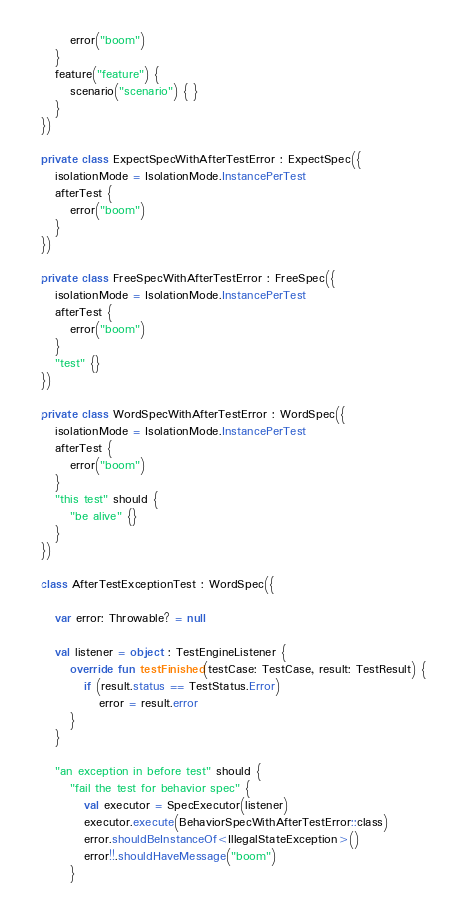Convert code to text. <code><loc_0><loc_0><loc_500><loc_500><_Kotlin_>      error("boom")
   }
   feature("feature") {
      scenario("scenario") { }
   }
})

private class ExpectSpecWithAfterTestError : ExpectSpec({
   isolationMode = IsolationMode.InstancePerTest
   afterTest {
      error("boom")
   }
})

private class FreeSpecWithAfterTestError : FreeSpec({
   isolationMode = IsolationMode.InstancePerTest
   afterTest {
      error("boom")
   }
   "test" {}
})

private class WordSpecWithAfterTestError : WordSpec({
   isolationMode = IsolationMode.InstancePerTest
   afterTest {
      error("boom")
   }
   "this test" should {
      "be alive" {}
   }
})

class AfterTestExceptionTest : WordSpec({

   var error: Throwable? = null

   val listener = object : TestEngineListener {
      override fun testFinished(testCase: TestCase, result: TestResult) {
         if (result.status == TestStatus.Error)
            error = result.error
      }
   }

   "an exception in before test" should {
      "fail the test for behavior spec" {
         val executor = SpecExecutor(listener)
         executor.execute(BehaviorSpecWithAfterTestError::class)
         error.shouldBeInstanceOf<IllegalStateException>()
         error!!.shouldHaveMessage("boom")
      }</code> 